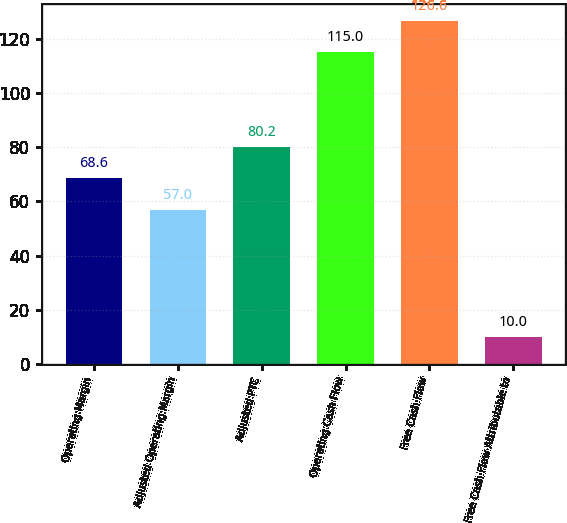Convert chart. <chart><loc_0><loc_0><loc_500><loc_500><bar_chart><fcel>Operating Margin<fcel>Adjusted Operating Margin<fcel>Adjusted PTC<fcel>Operating Cash Flow<fcel>Free Cash Flow<fcel>Free Cash Flow Attributable to<nl><fcel>68.6<fcel>57<fcel>80.2<fcel>115<fcel>126.6<fcel>10<nl></chart> 